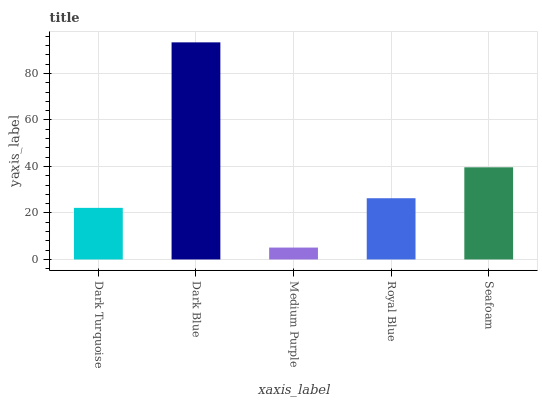Is Dark Blue the minimum?
Answer yes or no. No. Is Medium Purple the maximum?
Answer yes or no. No. Is Dark Blue greater than Medium Purple?
Answer yes or no. Yes. Is Medium Purple less than Dark Blue?
Answer yes or no. Yes. Is Medium Purple greater than Dark Blue?
Answer yes or no. No. Is Dark Blue less than Medium Purple?
Answer yes or no. No. Is Royal Blue the high median?
Answer yes or no. Yes. Is Royal Blue the low median?
Answer yes or no. Yes. Is Dark Blue the high median?
Answer yes or no. No. Is Medium Purple the low median?
Answer yes or no. No. 